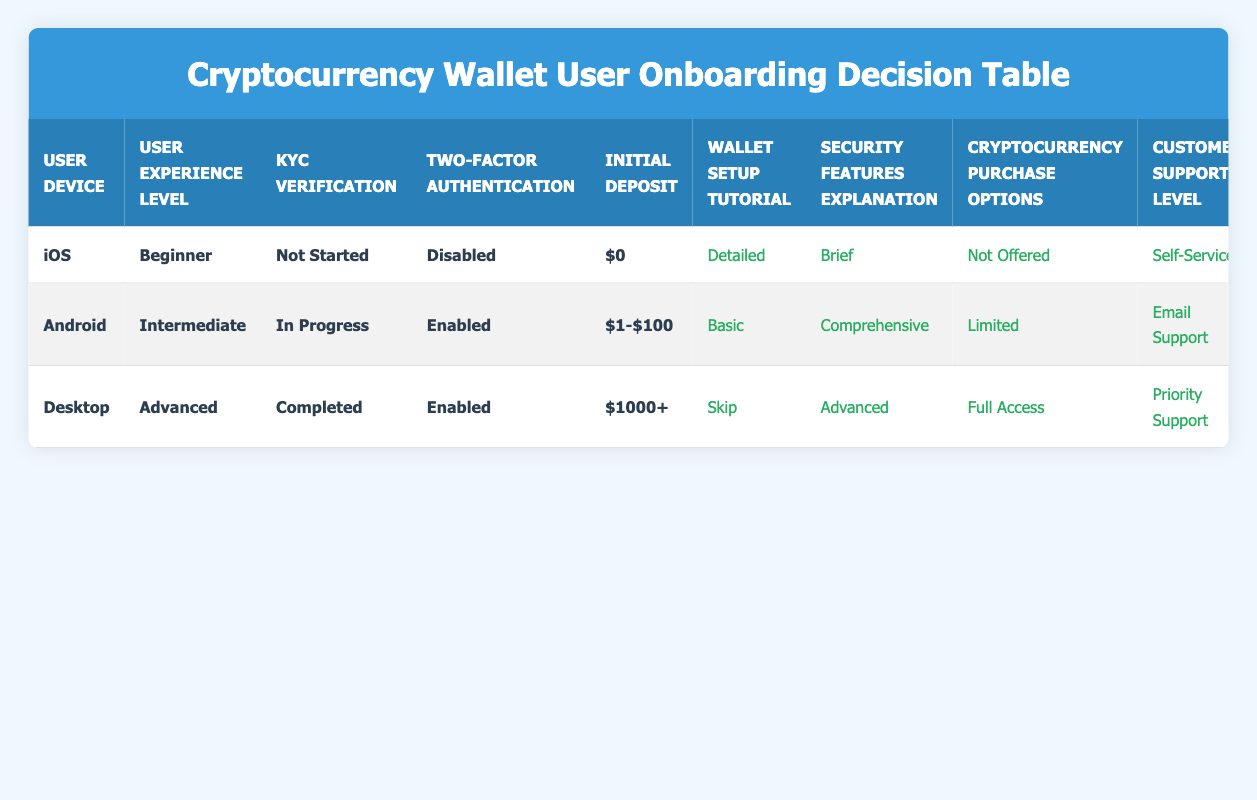What is the support level for an iOS beginner user who has not started KYC verification and has disabled two-factor authentication? The table shows the corresponding actions for users based on their conditions. For the iOS beginner user with "Not Started" KYC verification and "Disabled" two-factor authentication, the "Customer Support Level" is listed as "Self-Service."
Answer: Self-Service What type of wallet setup tutorial does an Android intermediate user receive when KYC verification is in progress and two-factor authentication is enabled? According to the table, this user falls under the conditions that specify they should receive a "Basic" wallet setup tutorial. Therefore, the corresponding action is "Basic."
Answer: Basic True or False: An advanced desktop user with completed KYC verification and an initial deposit of over $1000 receives comprehensive security features explanation. The table indicates that for a desktop advanced user with completed KYC, the action listed is an "Advanced" security features explanation, not "Comprehensive." Thus, the statement is false.
Answer: False What are the cryptocurrency purchase options for an iOS beginner who has not started KYC verification and has made an initial deposit of $0? By checking the table, the iOS beginner with those specific conditions is shown as receiving "Not Offered" for cryptocurrency purchase options. This response is directly described in the actions.
Answer: Not Offered How does the support level differ between an Android intermediate user and a desktop advanced user? Referring to the table, the Android intermediate user has an "Email Support" level, while the desktop advanced user has "Priority Support." The difference shows that priority support is a higher level of assistance compared to email support, indicating better service for the desktop user.
Answer: Email Support; Priority Support If a user on an iOS device is a beginner and enables two-factor authentication, how does it affect their wallet setup tutorial? The scenario describes an iOS beginner user who would still follow the original rules laid out for beginners. The table specifies that the wallet setup tutorial remains "Detailed," unaffected by the two-factor authentication change.
Answer: Detailed What is the difference in account limits between an Android intermediate user and a desktop advanced user? The table states that the Android intermediate user has "Intermediate" account limits, whereas the desktop advanced user is assigned "Advanced" limits. The difference implies that the desktop user has higher capabilities in terms of transactions.
Answer: Intermediate; Advanced Which user configuration has the highest level of customer support based on the conditions in the table? The table shows three users, and the desktop advanced user has "Priority Support," which is the highest level of customer support across all user configurations listed. This conclusion comes from directly comparing each listed support level.
Answer: Priority Support 